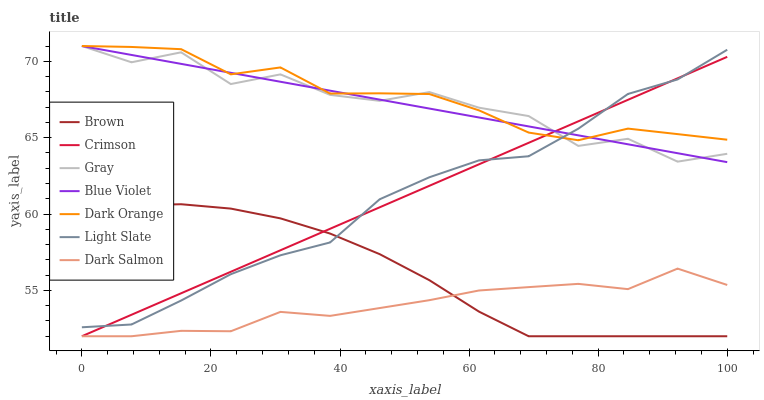Does Dark Salmon have the minimum area under the curve?
Answer yes or no. Yes. Does Dark Orange have the maximum area under the curve?
Answer yes or no. Yes. Does Light Slate have the minimum area under the curve?
Answer yes or no. No. Does Light Slate have the maximum area under the curve?
Answer yes or no. No. Is Crimson the smoothest?
Answer yes or no. Yes. Is Gray the roughest?
Answer yes or no. Yes. Is Dark Orange the smoothest?
Answer yes or no. No. Is Dark Orange the roughest?
Answer yes or no. No. Does Brown have the lowest value?
Answer yes or no. Yes. Does Light Slate have the lowest value?
Answer yes or no. No. Does Blue Violet have the highest value?
Answer yes or no. Yes. Does Light Slate have the highest value?
Answer yes or no. No. Is Dark Salmon less than Light Slate?
Answer yes or no. Yes. Is Dark Orange greater than Dark Salmon?
Answer yes or no. Yes. Does Light Slate intersect Gray?
Answer yes or no. Yes. Is Light Slate less than Gray?
Answer yes or no. No. Is Light Slate greater than Gray?
Answer yes or no. No. Does Dark Salmon intersect Light Slate?
Answer yes or no. No. 